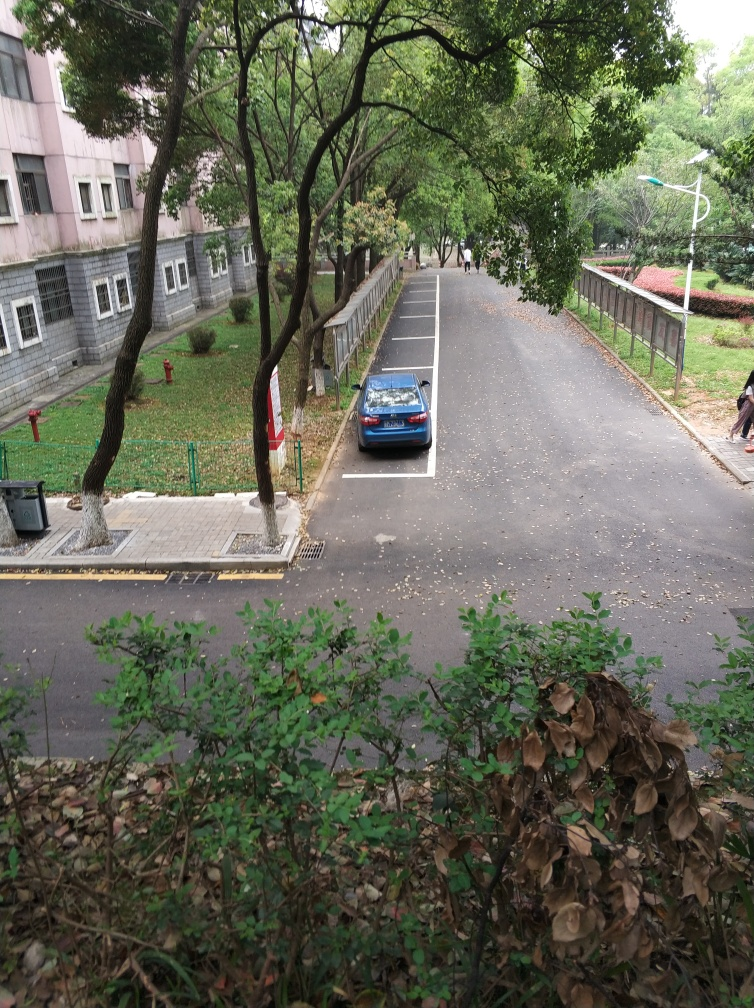Can you describe any indications of recent activity in this scene? Yes, there are fallen leaves scattered across the pavement, which suggest that they have not been swept recently, and a solitary car is parked, which could imply a peaceful time of day without much traffic. 